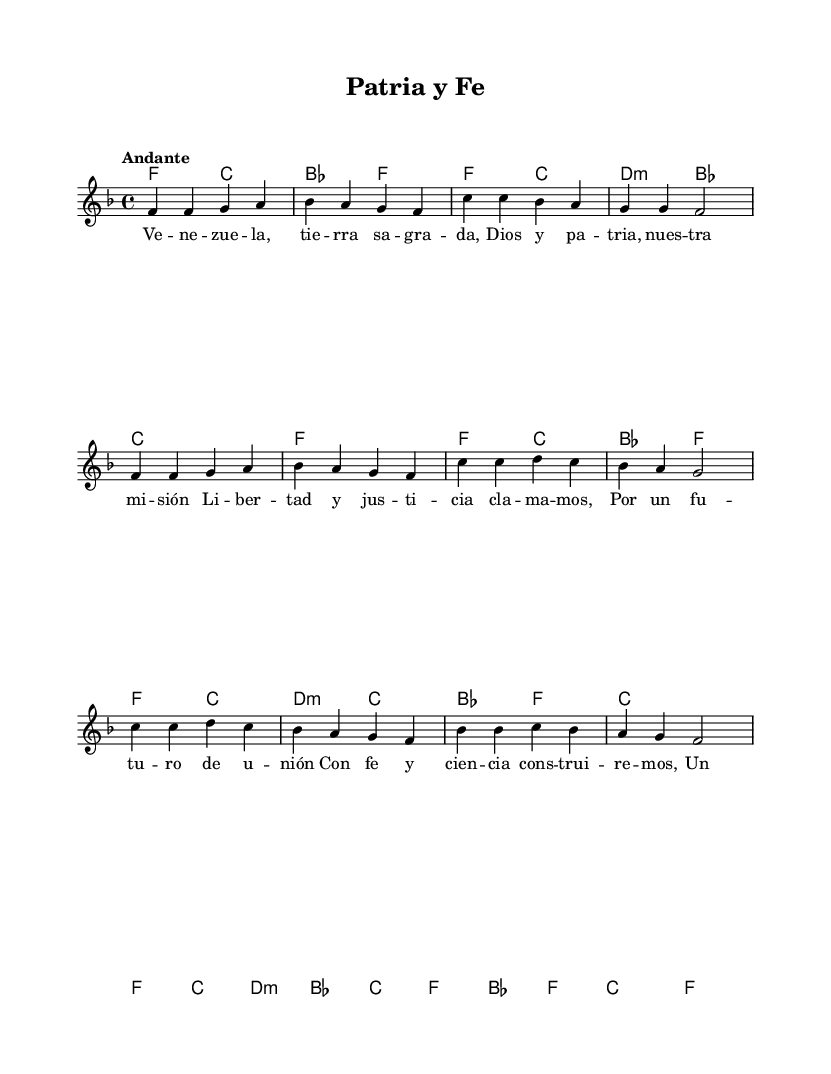What is the key signature of this music? The key signature is F major, which has one flat (B flat). This can be identified by looking at the key signature indicated at the beginning of the music.
Answer: F major What is the time signature of this piece? The time signature is 4/4, which indicates that each measure contains four beats, and each quarter note receives one beat. This is shown at the start of the score after the key signature.
Answer: 4/4 What is the tempo marking for the music? The tempo marking is "Andante," which suggests a moderately slow pace. This can be seen in the tempo indication placed above the staff.
Answer: Andante How many measures are in the melody? There are 12 measures in the melody, which can be counted by identifying the vertical lines that separate the measures in the staff.
Answer: 12 Which phrases reflect political undertones in the lyrics? The phrases "Libertad y justicia clamamos" and "Por un futuro de unión" suggest political themes like freedom and unity. These can be determined by analyzing the context and wording of the lyrics provided.
Answer: Libertad y justicia clamamos; Por un futuro de unión What is the harmonic progression in the first four measures? The harmonic progression in the first four measures is F major to C major to B flat major to F major. This is analyzed by looking at the chord symbols indicated below the melody in those measures.
Answer: F, C, B flat, F 